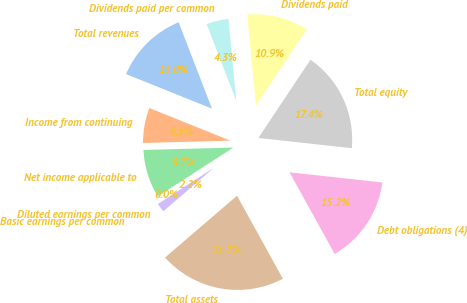<chart> <loc_0><loc_0><loc_500><loc_500><pie_chart><fcel>Total revenues<fcel>Income from continuing<fcel>Net income applicable to<fcel>Basic earnings per common<fcel>Diluted earnings per common<fcel>Total assets<fcel>Debt obligations (4)<fcel>Total equity<fcel>Dividends paid<fcel>Dividends paid per common<nl><fcel>13.04%<fcel>6.52%<fcel>8.7%<fcel>0.0%<fcel>2.17%<fcel>21.74%<fcel>15.22%<fcel>17.39%<fcel>10.87%<fcel>4.35%<nl></chart> 